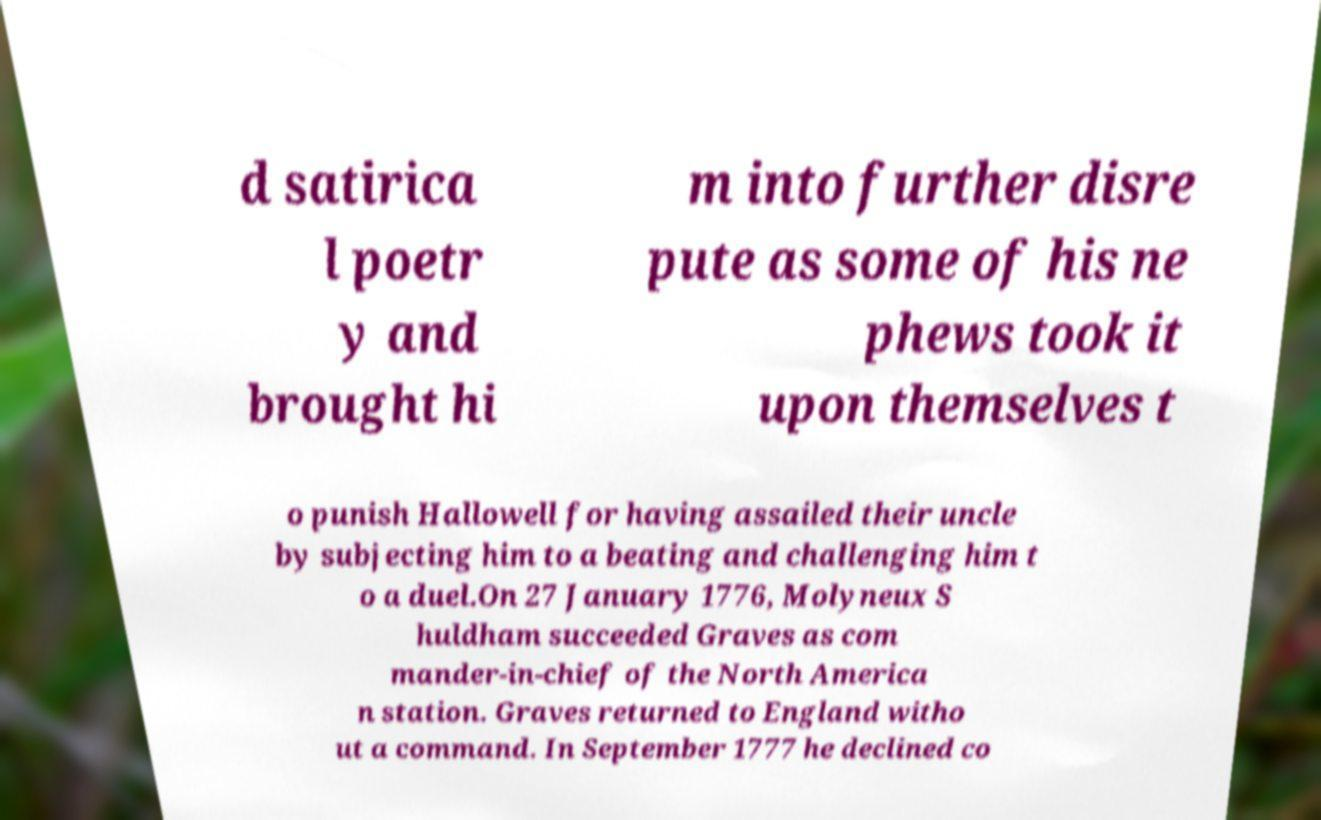There's text embedded in this image that I need extracted. Can you transcribe it verbatim? d satirica l poetr y and brought hi m into further disre pute as some of his ne phews took it upon themselves t o punish Hallowell for having assailed their uncle by subjecting him to a beating and challenging him t o a duel.On 27 January 1776, Molyneux S huldham succeeded Graves as com mander-in-chief of the North America n station. Graves returned to England witho ut a command. In September 1777 he declined co 